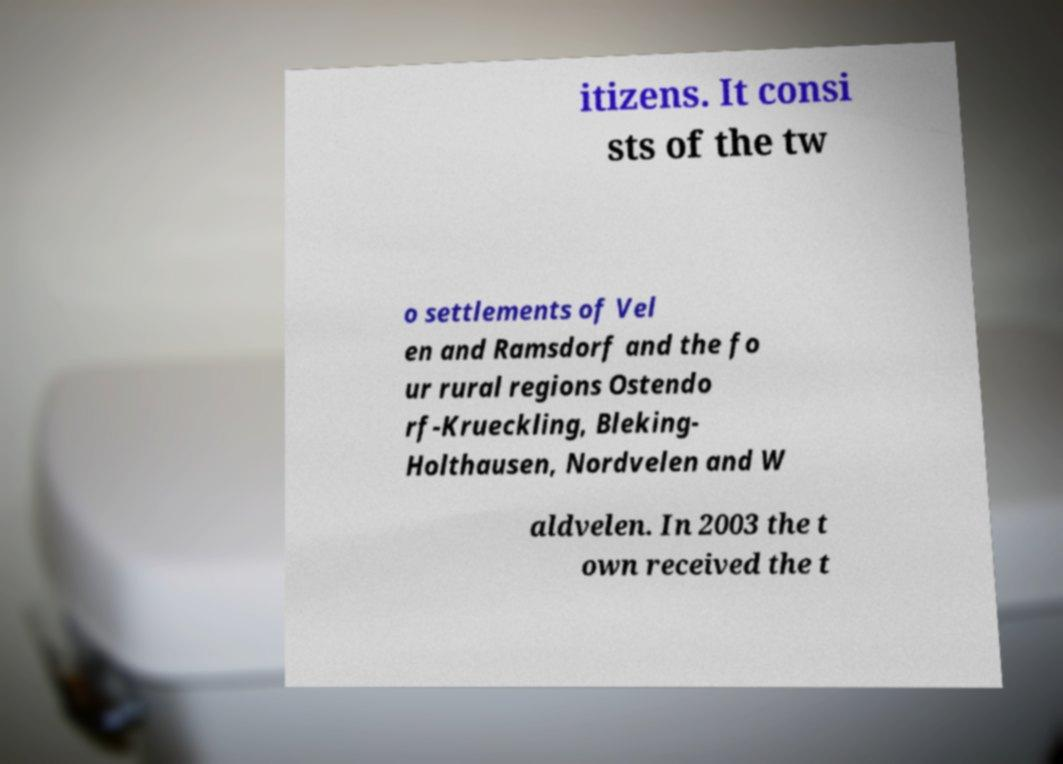Please read and relay the text visible in this image. What does it say? itizens. It consi sts of the tw o settlements of Vel en and Ramsdorf and the fo ur rural regions Ostendo rf-Krueckling, Bleking- Holthausen, Nordvelen and W aldvelen. In 2003 the t own received the t 